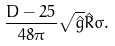<formula> <loc_0><loc_0><loc_500><loc_500>\frac { D - 2 5 } { 4 8 \pi } \sqrt { \hat { g } } \hat { R } \sigma .</formula> 